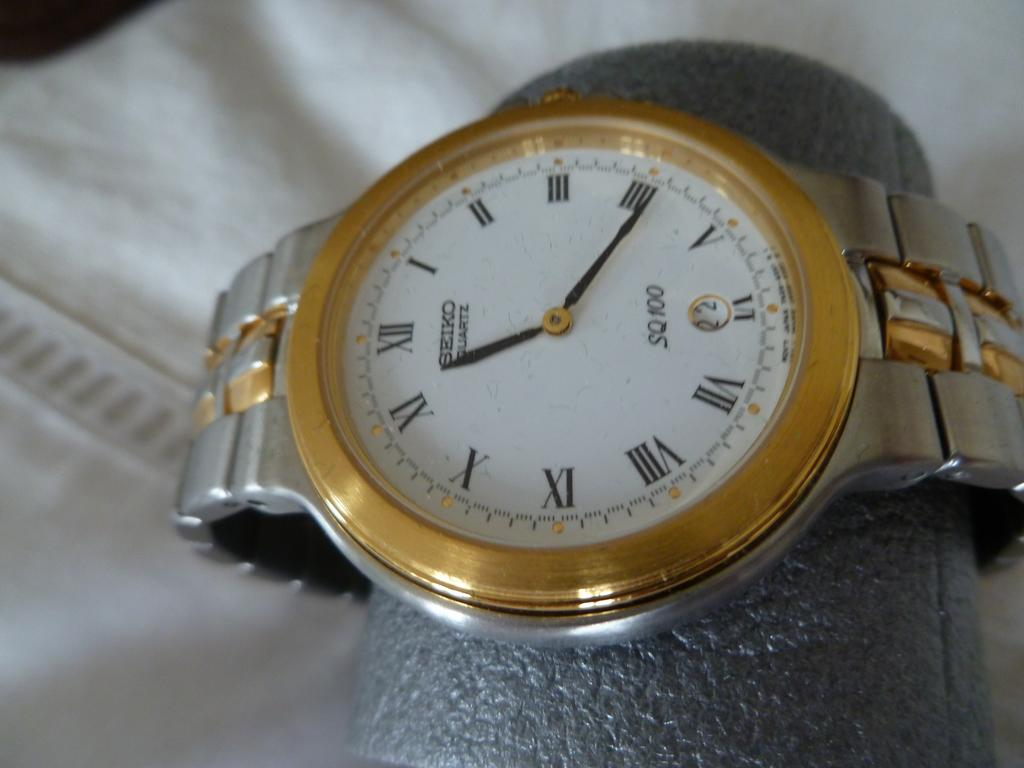<image>
Create a compact narrative representing the image presented. a gold and white seiko watch and roman numeral clock 